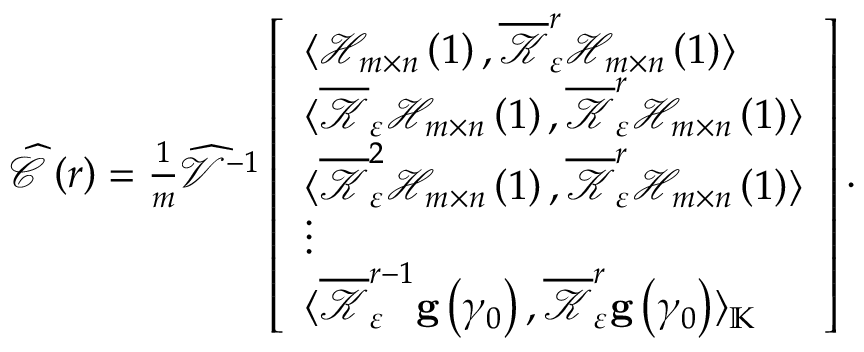<formula> <loc_0><loc_0><loc_500><loc_500>\begin{array} { r } { \widehat { \mathcal { C } } \left ( r \right ) = \frac { 1 } { m } \widehat { \mathcal { V } } ^ { - 1 } \left [ \begin{array} { l } { \langle \mathcal { H } _ { m \times n } \left ( 1 \right ) , \overline { { \mathcal { K } } } _ { \varepsilon } ^ { r } \mathcal { H } _ { m \times n } \left ( 1 \right ) \rangle } \\ { \langle \overline { { \mathcal { K } } } _ { \varepsilon } \mathcal { H } _ { m \times n } \left ( 1 \right ) , \overline { { \mathcal { K } } } _ { \varepsilon } ^ { r } \mathcal { H } _ { m \times n } \left ( 1 \right ) \rangle } \\ { \langle \overline { { \mathcal { K } } } _ { \varepsilon } ^ { 2 } \mathcal { H } _ { m \times n } \left ( 1 \right ) , \overline { { \mathcal { K } } } _ { \varepsilon } ^ { r } \mathcal { H } _ { m \times n } \left ( 1 \right ) \rangle } \\ { \vdots } \\ { \langle \overline { { \mathcal { K } } } _ { \varepsilon } ^ { r - 1 } g \left ( \gamma _ { 0 } \right ) , \overline { { \mathcal { K } } } _ { \varepsilon } ^ { r } g \left ( \gamma _ { 0 } \right ) \rangle _ { \mathbb { K } } } \end{array} \right ] . } \end{array}</formula> 